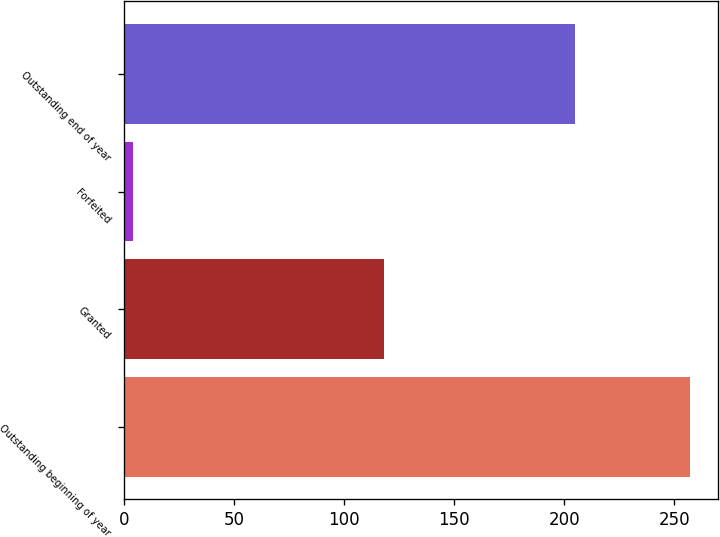Convert chart to OTSL. <chart><loc_0><loc_0><loc_500><loc_500><bar_chart><fcel>Outstanding beginning of year<fcel>Granted<fcel>Forfeited<fcel>Outstanding end of year<nl><fcel>257<fcel>118<fcel>4<fcel>205<nl></chart> 